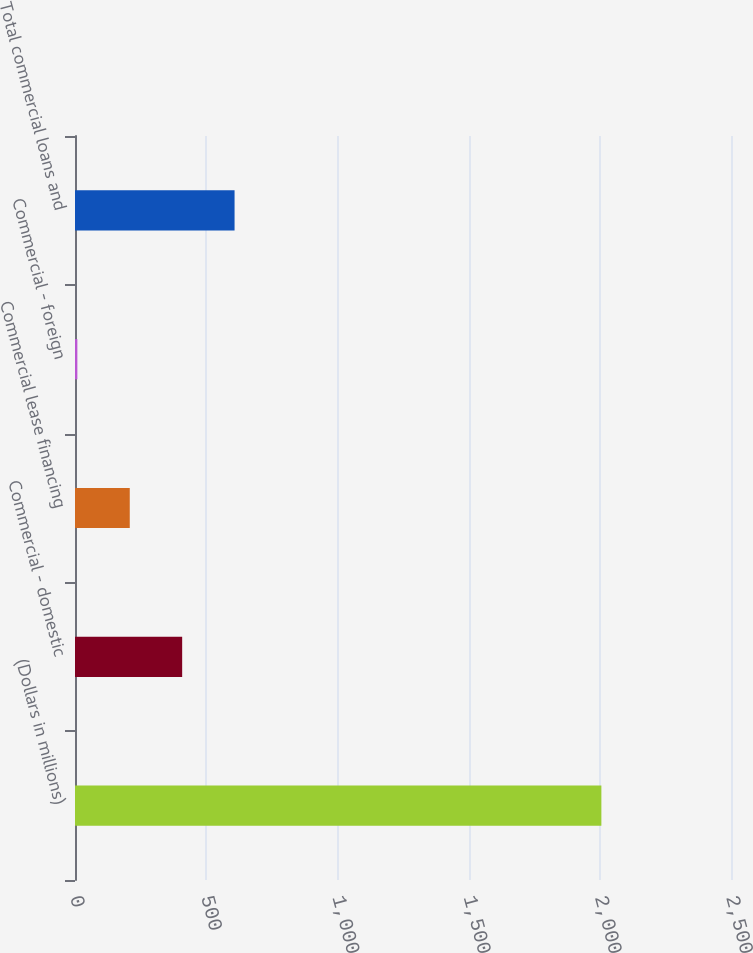<chart> <loc_0><loc_0><loc_500><loc_500><bar_chart><fcel>(Dollars in millions)<fcel>Commercial - domestic<fcel>Commercial lease financing<fcel>Commercial - foreign<fcel>Total commercial loans and<nl><fcel>2006<fcel>408.4<fcel>208.7<fcel>9<fcel>608.1<nl></chart> 